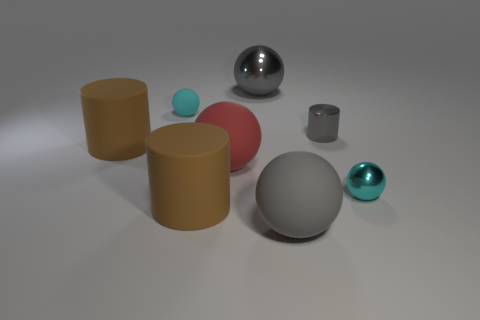Subtract 1 spheres. How many spheres are left? 4 Subtract all red spheres. How many spheres are left? 4 Subtract all big red balls. How many balls are left? 4 Subtract all blue balls. Subtract all gray cylinders. How many balls are left? 5 Add 1 big purple metallic spheres. How many objects exist? 9 Subtract all cylinders. How many objects are left? 5 Subtract 0 purple cylinders. How many objects are left? 8 Subtract all matte balls. Subtract all big metal objects. How many objects are left? 4 Add 2 tiny cyan rubber objects. How many tiny cyan rubber objects are left? 3 Add 7 small gray cylinders. How many small gray cylinders exist? 8 